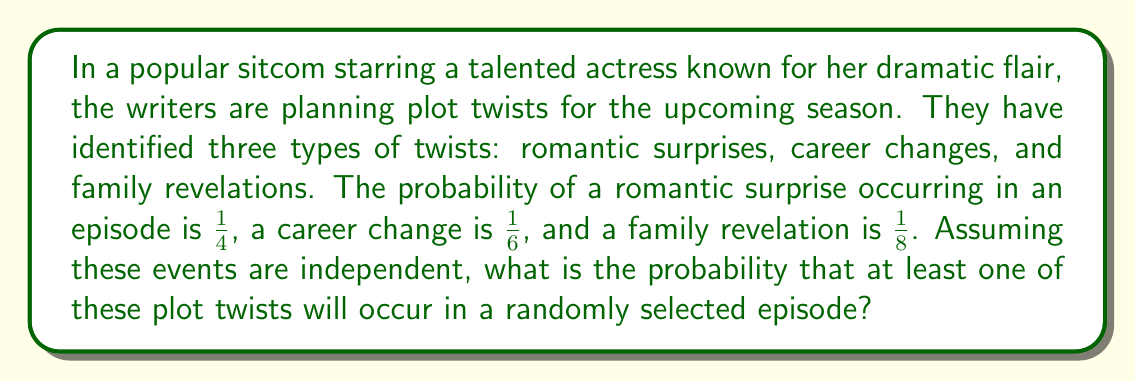Could you help me with this problem? To solve this problem, we'll use the complement rule of probability. Instead of calculating the probability of at least one twist occurring, we'll calculate the probability of no twists occurring and then subtract that from 1.

Let's define our events:
R: Romantic surprise
C: Career change
F: Family revelation

We want to find P(at least one twist) = 1 - P(no twists)

P(no twists) = P(not R and not C and not F)

Since the events are independent, we can multiply the probabilities of each event not occurring:

P(no twists) = P(not R) × P(not C) × P(not F)

P(not R) = 1 - P(R) = 1 - $\frac{1}{4}$ = $\frac{3}{4}$
P(not C) = 1 - P(C) = 1 - $\frac{1}{6}$ = $\frac{5}{6}$
P(not F) = 1 - P(F) = 1 - $\frac{1}{8}$ = $\frac{7}{8}$

Now, let's multiply these probabilities:

P(no twists) = $\frac{3}{4}$ × $\frac{5}{6}$ × $\frac{7}{8}$ = $\frac{105}{192}$

Finally, we can calculate the probability of at least one twist occurring:

P(at least one twist) = 1 - P(no twists)
                      = 1 - $\frac{105}{192}$
                      = $\frac{192}{192}$ - $\frac{105}{192}$
                      = $\frac{87}{192}$
                      ≈ 0.4531 or about 45.31%
Answer: The probability that at least one of these plot twists will occur in a randomly selected episode is $\frac{87}{192}$ or approximately 45.31%. 